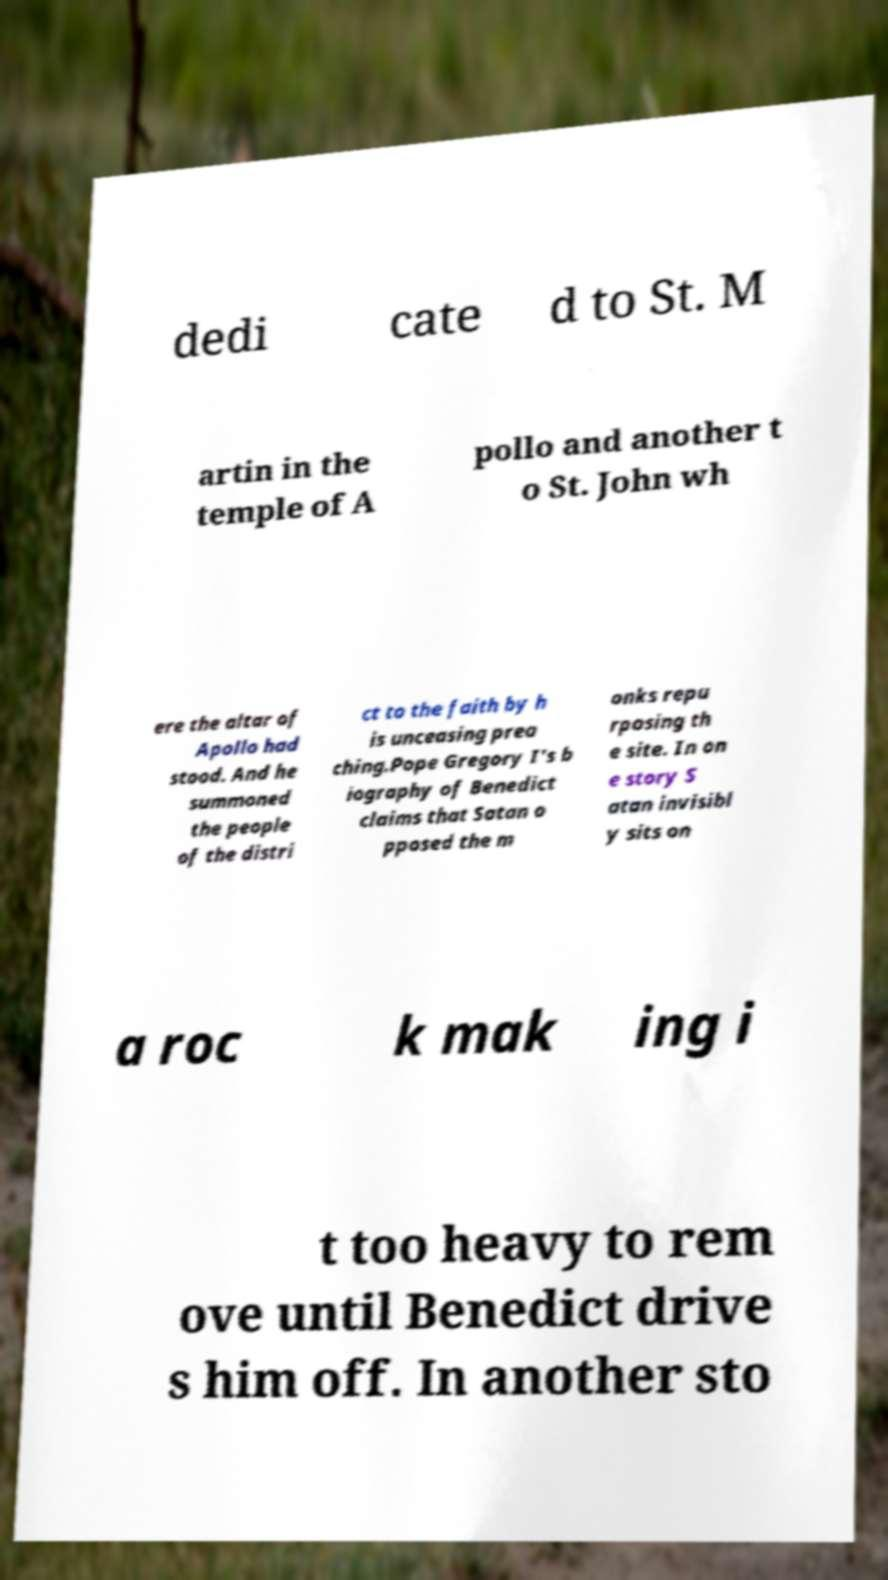I need the written content from this picture converted into text. Can you do that? dedi cate d to St. M artin in the temple of A pollo and another t o St. John wh ere the altar of Apollo had stood. And he summoned the people of the distri ct to the faith by h is unceasing prea ching.Pope Gregory I's b iography of Benedict claims that Satan o pposed the m onks repu rposing th e site. In on e story S atan invisibl y sits on a roc k mak ing i t too heavy to rem ove until Benedict drive s him off. In another sto 